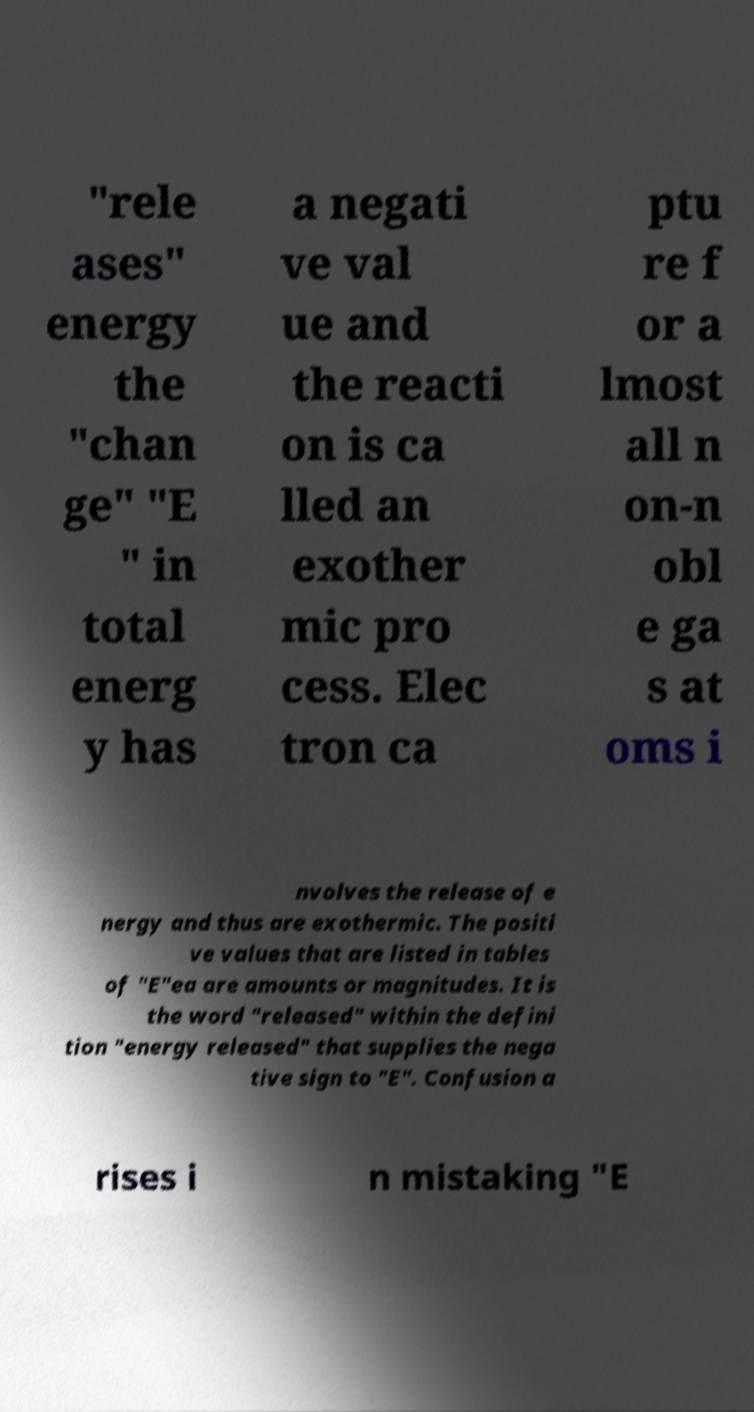Can you read and provide the text displayed in the image?This photo seems to have some interesting text. Can you extract and type it out for me? "rele ases" energy the "chan ge" "E " in total energ y has a negati ve val ue and the reacti on is ca lled an exother mic pro cess. Elec tron ca ptu re f or a lmost all n on-n obl e ga s at oms i nvolves the release of e nergy and thus are exothermic. The positi ve values that are listed in tables of "E"ea are amounts or magnitudes. It is the word "released" within the defini tion "energy released" that supplies the nega tive sign to "E". Confusion a rises i n mistaking "E 